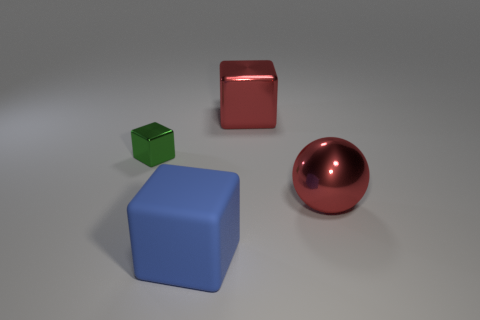Is there any other thing that is the same material as the big blue thing?
Make the answer very short. No. Is there a red thing of the same size as the green cube?
Your answer should be compact. No. There is a big ball; is its color the same as the shiny cube to the right of the big blue rubber object?
Keep it short and to the point. Yes. What number of blocks are in front of the metal object on the left side of the red metal block?
Your answer should be very brief. 1. The big metal thing that is behind the red thing that is on the right side of the red block is what color?
Provide a short and direct response. Red. The big thing that is in front of the small green cube and to the right of the matte object is made of what material?
Make the answer very short. Metal. Is there a large blue rubber thing of the same shape as the small green object?
Make the answer very short. Yes. Is the shape of the red metallic object in front of the tiny thing the same as  the blue thing?
Ensure brevity in your answer.  No. What number of objects are in front of the big metallic sphere and to the left of the big blue object?
Provide a succinct answer. 0. The shiny object in front of the green cube has what shape?
Ensure brevity in your answer.  Sphere. 